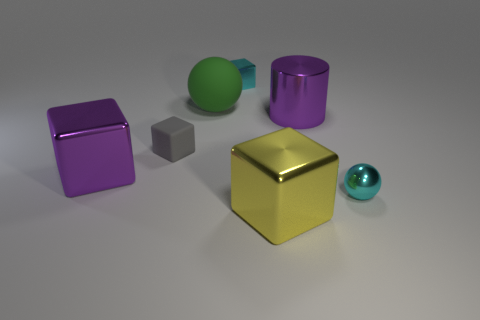Subtract all cyan blocks. How many blocks are left? 3 Add 3 yellow shiny blocks. How many objects exist? 10 Subtract all gray matte blocks. How many blocks are left? 3 Subtract all balls. How many objects are left? 5 Subtract all red spheres. How many cyan cylinders are left? 0 Add 5 tiny spheres. How many tiny spheres are left? 6 Add 4 yellow matte spheres. How many yellow matte spheres exist? 4 Subtract 1 purple cubes. How many objects are left? 6 Subtract 2 balls. How many balls are left? 0 Subtract all yellow balls. Subtract all gray cubes. How many balls are left? 2 